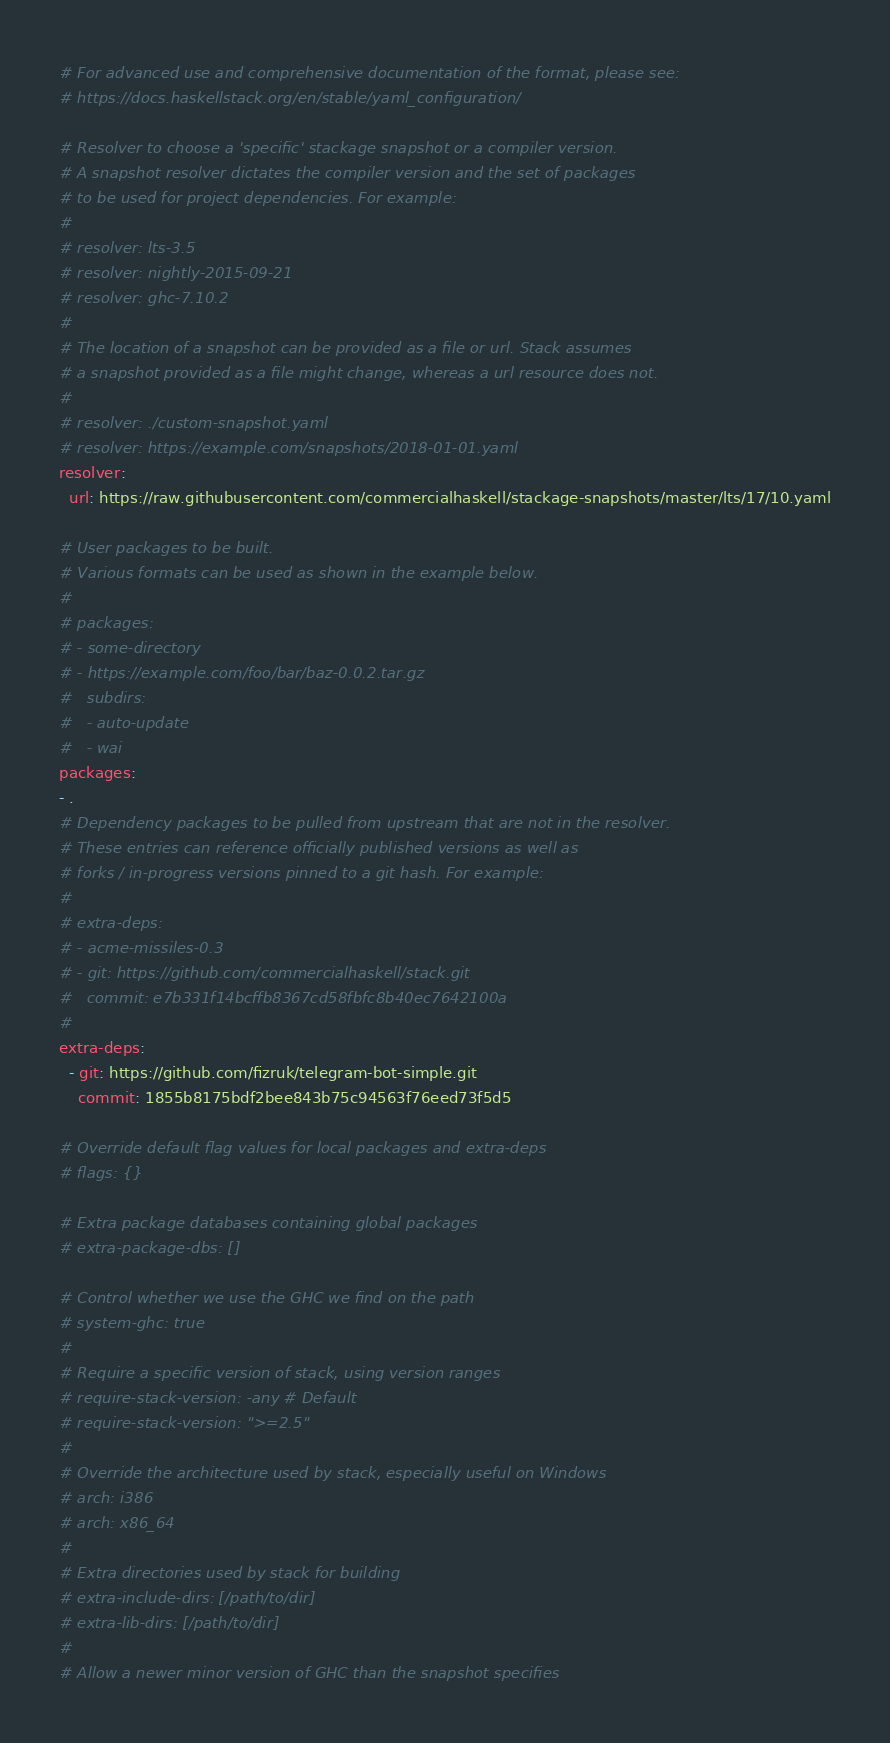<code> <loc_0><loc_0><loc_500><loc_500><_YAML_># For advanced use and comprehensive documentation of the format, please see:
# https://docs.haskellstack.org/en/stable/yaml_configuration/

# Resolver to choose a 'specific' stackage snapshot or a compiler version.
# A snapshot resolver dictates the compiler version and the set of packages
# to be used for project dependencies. For example:
#
# resolver: lts-3.5
# resolver: nightly-2015-09-21
# resolver: ghc-7.10.2
#
# The location of a snapshot can be provided as a file or url. Stack assumes
# a snapshot provided as a file might change, whereas a url resource does not.
#
# resolver: ./custom-snapshot.yaml
# resolver: https://example.com/snapshots/2018-01-01.yaml
resolver:
  url: https://raw.githubusercontent.com/commercialhaskell/stackage-snapshots/master/lts/17/10.yaml

# User packages to be built.
# Various formats can be used as shown in the example below.
#
# packages:
# - some-directory
# - https://example.com/foo/bar/baz-0.0.2.tar.gz
#   subdirs:
#   - auto-update
#   - wai
packages:
- .
# Dependency packages to be pulled from upstream that are not in the resolver.
# These entries can reference officially published versions as well as
# forks / in-progress versions pinned to a git hash. For example:
#
# extra-deps:
# - acme-missiles-0.3
# - git: https://github.com/commercialhaskell/stack.git
#   commit: e7b331f14bcffb8367cd58fbfc8b40ec7642100a
#
extra-deps:
  - git: https://github.com/fizruk/telegram-bot-simple.git
    commit: 1855b8175bdf2bee843b75c94563f76eed73f5d5

# Override default flag values for local packages and extra-deps
# flags: {}

# Extra package databases containing global packages
# extra-package-dbs: []

# Control whether we use the GHC we find on the path
# system-ghc: true
#
# Require a specific version of stack, using version ranges
# require-stack-version: -any # Default
# require-stack-version: ">=2.5"
#
# Override the architecture used by stack, especially useful on Windows
# arch: i386
# arch: x86_64
#
# Extra directories used by stack for building
# extra-include-dirs: [/path/to/dir]
# extra-lib-dirs: [/path/to/dir]
#
# Allow a newer minor version of GHC than the snapshot specifies</code> 